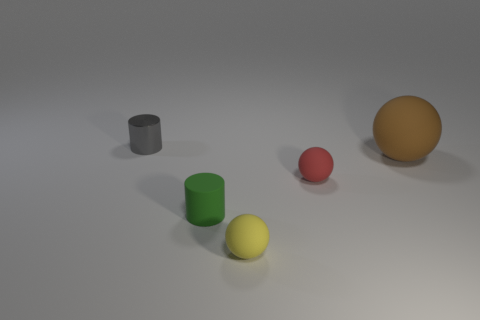Can you describe the lighting and shadows seen in the image? The image shows a gentle lighting scenario from the upper left, creating soft shadows that trail to the lower right side of the objects. This suggests a diffused light source, contributing to the tranquil and minimalist atmosphere of the scene. 